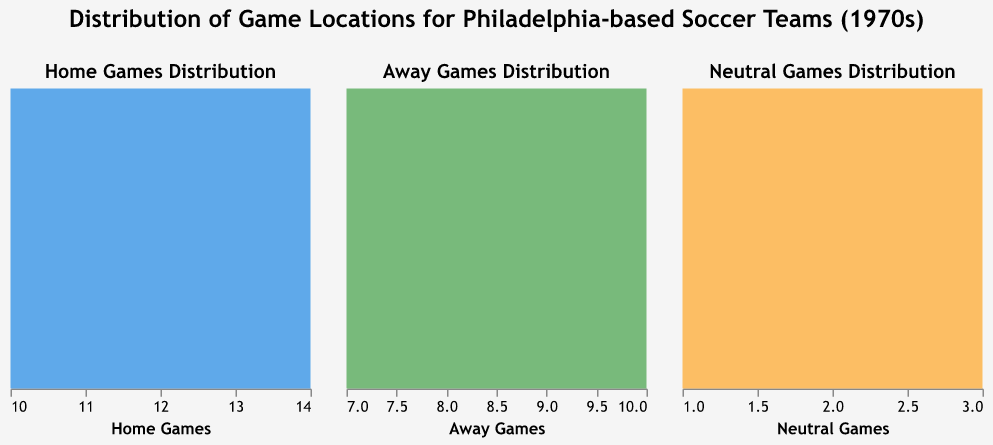What's the title of the figure? The title is displayed at the top of the figure in bold letters and reads: "Distribution of Game Locations for Philadelphia-based Soccer Teams (1970s)"
Answer: Distribution of Game Locations for Philadelphia-based Soccer Teams (1970s) How many teams are represented in the data? Each subplot represents game data for five teams, confirmed by the number of tooltips that appear in the visualization.
Answer: Five Which team has the highest number of home games? The subplot labeled "Home Games Distribution" shows the highest density at the value 14, corresponding to Lancaster Inferno based on tooltip information.
Answer: Lancaster Inferno What is the color representing home games in the figure? From the figure, the area under "Home Games Distribution" is filled with a blue color.
Answer: Blue How many neutral games did the Upland Highlanders play? Observing the "Neutral Games Distribution" subplot, a density peak at value 3 corresponds to the Upland Highlanders, as seen from the tooltip.
Answer: Three Which team has the least number of away games and how many did they play? The subplot "Away Games Distribution" shows the lowest density at the value 7, which when hovered upon reveals the team Lancaster Inferno by the tooltip.
Answer: Lancaster Inferno, seven Are there any teams that played an equal number of away games? In the "Away Games Distribution" subplot, Philadelphia Fury and Upland Highlanders both have peaks at value 9, indicating they played an equal number of away games.
Answer: Philadelphia Fury and Upland Highlanders What is the smallest number of neutral games any team played? The "Neutral Games Distribution" subplot shows the smallest density at value 1 by observing the lowest peak, which applies to Philadelphia Atoms, Philadelphia Fury, and Lancaster Inferno.
Answer: One Which team had the most balanced distribution of home and away games? Comparing the home and away game subplots, Philadelphia Atoms shows similar densities at 11 (home) and 10 (away) games, suggesting the balance between home and away games.
Answer: Philadelphia Atoms 